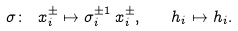Convert formula to latex. <formula><loc_0><loc_0><loc_500><loc_500>\sigma \colon \ x _ { i } ^ { \pm } \mapsto \sigma _ { i } ^ { \pm 1 } \, x ^ { \pm } _ { i } , \quad h _ { i } \mapsto h _ { i } .</formula> 